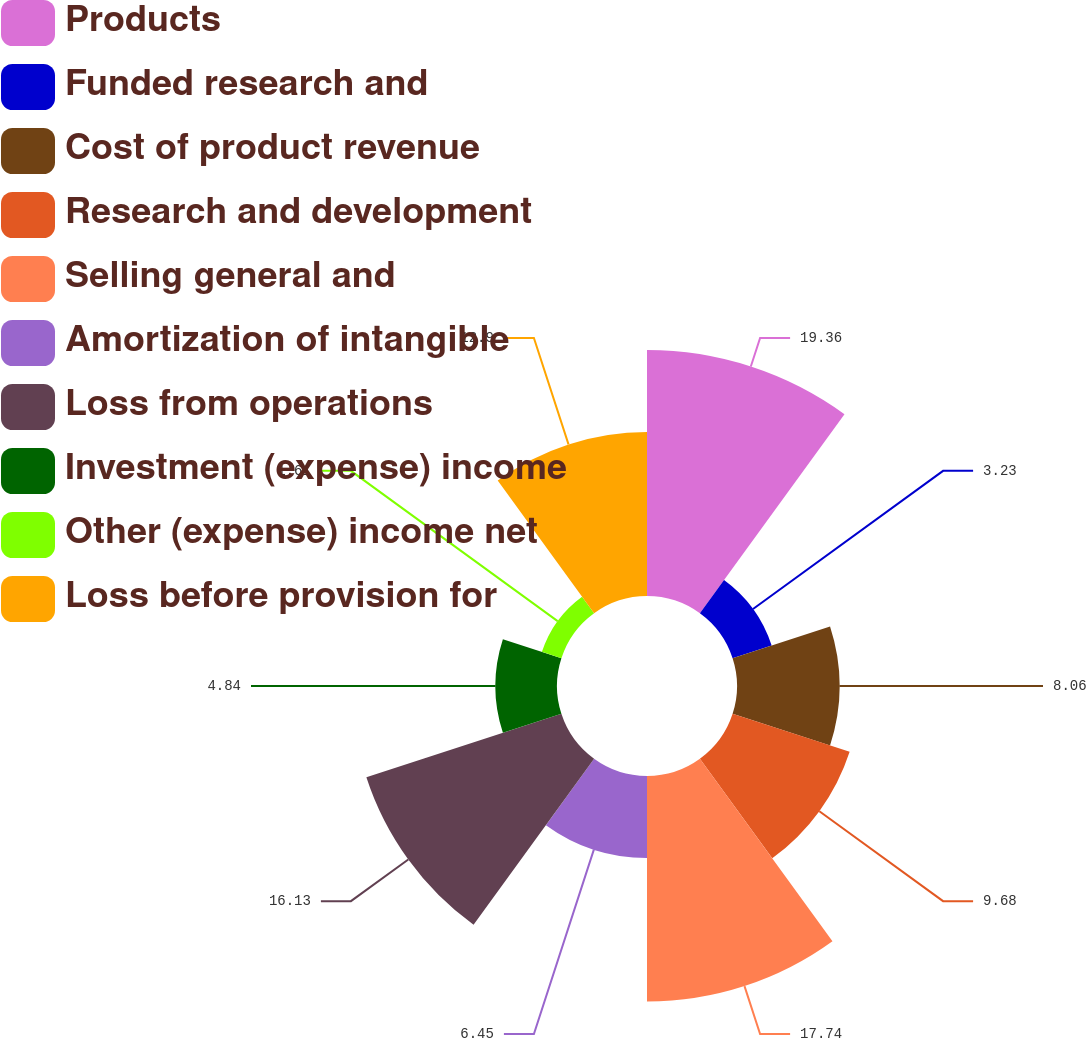Convert chart to OTSL. <chart><loc_0><loc_0><loc_500><loc_500><pie_chart><fcel>Products<fcel>Funded research and<fcel>Cost of product revenue<fcel>Research and development<fcel>Selling general and<fcel>Amortization of intangible<fcel>Loss from operations<fcel>Investment (expense) income<fcel>Other (expense) income net<fcel>Loss before provision for<nl><fcel>19.35%<fcel>3.23%<fcel>8.06%<fcel>9.68%<fcel>17.74%<fcel>6.45%<fcel>16.13%<fcel>4.84%<fcel>1.61%<fcel>12.9%<nl></chart> 